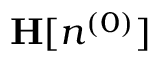<formula> <loc_0><loc_0><loc_500><loc_500>{ H } [ n ^ { ( 0 ) } ]</formula> 